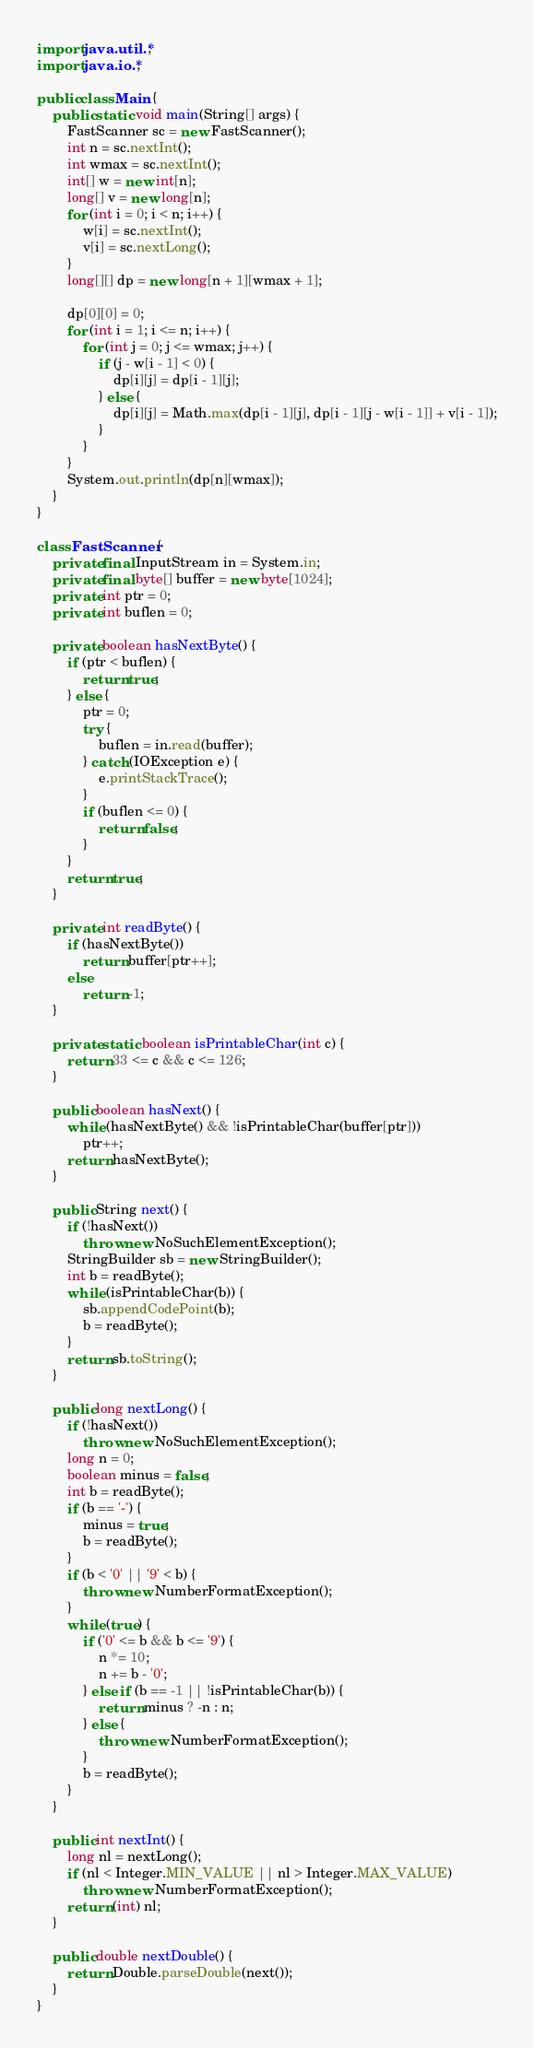Convert code to text. <code><loc_0><loc_0><loc_500><loc_500><_Java_>import java.util.*;
import java.io.*;

public class Main {
    public static void main(String[] args) {
        FastScanner sc = new FastScanner();
        int n = sc.nextInt();
        int wmax = sc.nextInt();
        int[] w = new int[n];
        long[] v = new long[n];
        for (int i = 0; i < n; i++) {
            w[i] = sc.nextInt();
            v[i] = sc.nextLong();
        }
        long[][] dp = new long[n + 1][wmax + 1];

        dp[0][0] = 0;
        for (int i = 1; i <= n; i++) {
            for (int j = 0; j <= wmax; j++) {
                if (j - w[i - 1] < 0) {
                    dp[i][j] = dp[i - 1][j];
                } else {
                    dp[i][j] = Math.max(dp[i - 1][j], dp[i - 1][j - w[i - 1]] + v[i - 1]);
                }
            }
        }
        System.out.println(dp[n][wmax]);
    }
}

class FastScanner {
    private final InputStream in = System.in;
    private final byte[] buffer = new byte[1024];
    private int ptr = 0;
    private int buflen = 0;

    private boolean hasNextByte() {
        if (ptr < buflen) {
            return true;
        } else {
            ptr = 0;
            try {
                buflen = in.read(buffer);
            } catch (IOException e) {
                e.printStackTrace();
            }
            if (buflen <= 0) {
                return false;
            }
        }
        return true;
    }

    private int readByte() {
        if (hasNextByte())
            return buffer[ptr++];
        else
            return -1;
    }

    private static boolean isPrintableChar(int c) {
        return 33 <= c && c <= 126;
    }

    public boolean hasNext() {
        while (hasNextByte() && !isPrintableChar(buffer[ptr]))
            ptr++;
        return hasNextByte();
    }

    public String next() {
        if (!hasNext())
            throw new NoSuchElementException();
        StringBuilder sb = new StringBuilder();
        int b = readByte();
        while (isPrintableChar(b)) {
            sb.appendCodePoint(b);
            b = readByte();
        }
        return sb.toString();
    }

    public long nextLong() {
        if (!hasNext())
            throw new NoSuchElementException();
        long n = 0;
        boolean minus = false;
        int b = readByte();
        if (b == '-') {
            minus = true;
            b = readByte();
        }
        if (b < '0' || '9' < b) {
            throw new NumberFormatException();
        }
        while (true) {
            if ('0' <= b && b <= '9') {
                n *= 10;
                n += b - '0';
            } else if (b == -1 || !isPrintableChar(b)) {
                return minus ? -n : n;
            } else {
                throw new NumberFormatException();
            }
            b = readByte();
        }
    }

    public int nextInt() {
        long nl = nextLong();
        if (nl < Integer.MIN_VALUE || nl > Integer.MAX_VALUE)
            throw new NumberFormatException();
        return (int) nl;
    }

    public double nextDouble() {
        return Double.parseDouble(next());
    }
}
</code> 